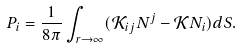<formula> <loc_0><loc_0><loc_500><loc_500>P _ { i } = \frac { 1 } { 8 \pi } \int _ { r \rightarrow \infty } ( \mathcal { K } _ { i j } N ^ { j } - \mathcal { K } N _ { i } ) d S .</formula> 